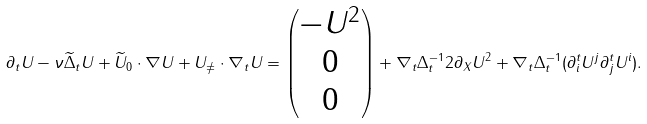<formula> <loc_0><loc_0><loc_500><loc_500>\partial _ { t } U - \nu \widetilde { \Delta } _ { t } U + \widetilde { U } _ { 0 } \cdot \nabla U + U _ { \neq } \cdot \nabla _ { t } U = \begin{pmatrix} - U ^ { 2 } \\ 0 \\ 0 \end{pmatrix} + \nabla _ { t } { \Delta } _ { t } ^ { - 1 } 2 \partial _ { X } U ^ { 2 } + \nabla _ { t } \Delta _ { t } ^ { - 1 } ( \partial ^ { t } _ { i } U ^ { j } \partial _ { j } ^ { t } U ^ { i } ) .</formula> 